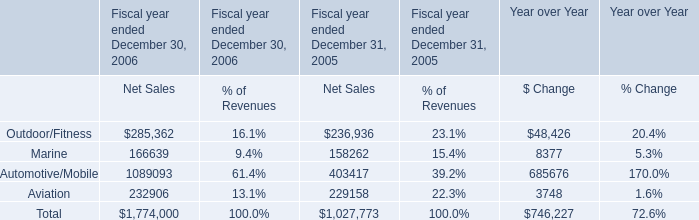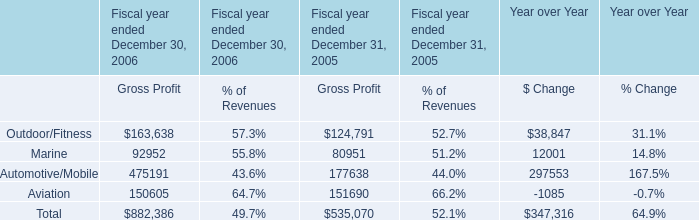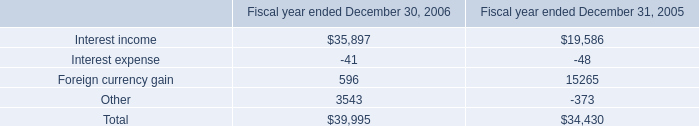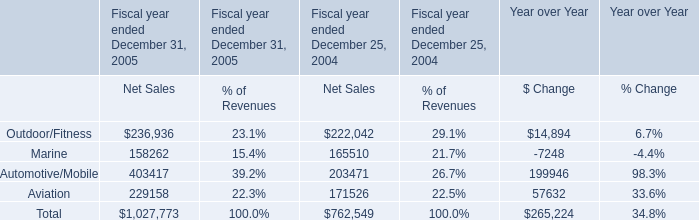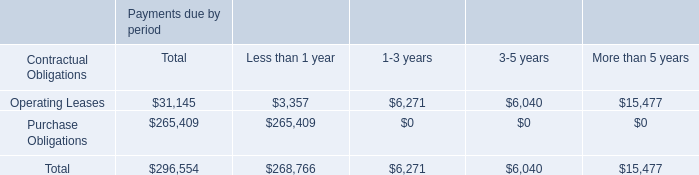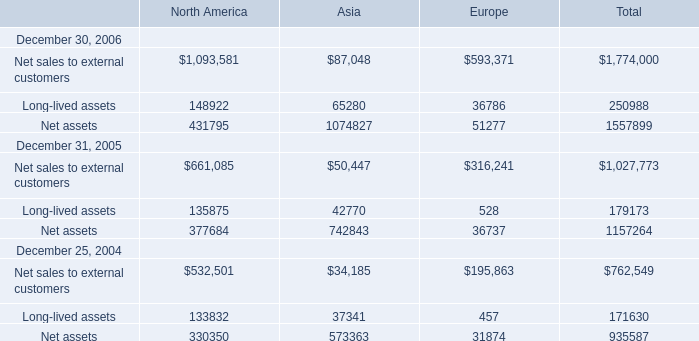What is the sum of Interest income of Fiscal year ended December 31, 2005, and Automotive/Mobile of Fiscal year ended December 31, 2005 Gross Profit ? 
Computations: (19586.0 + 177638.0)
Answer: 197224.0. 